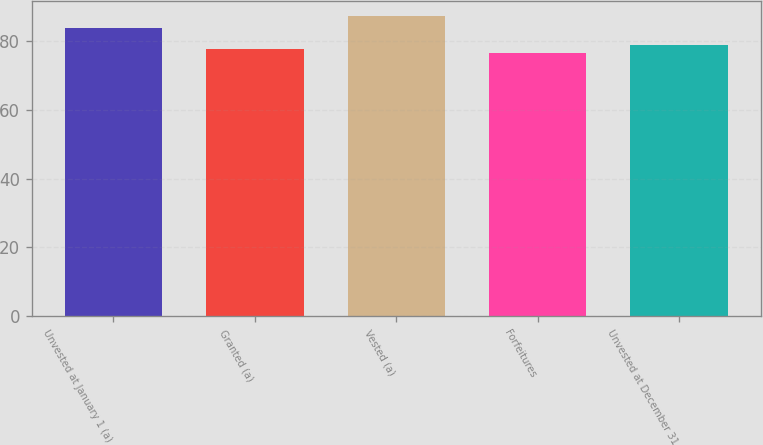Convert chart. <chart><loc_0><loc_0><loc_500><loc_500><bar_chart><fcel>Unvested at January 1 (a)<fcel>Granted (a)<fcel>Vested (a)<fcel>Forfeitures<fcel>Unvested at December 31<nl><fcel>83.75<fcel>77.51<fcel>87.27<fcel>76.43<fcel>78.72<nl></chart> 